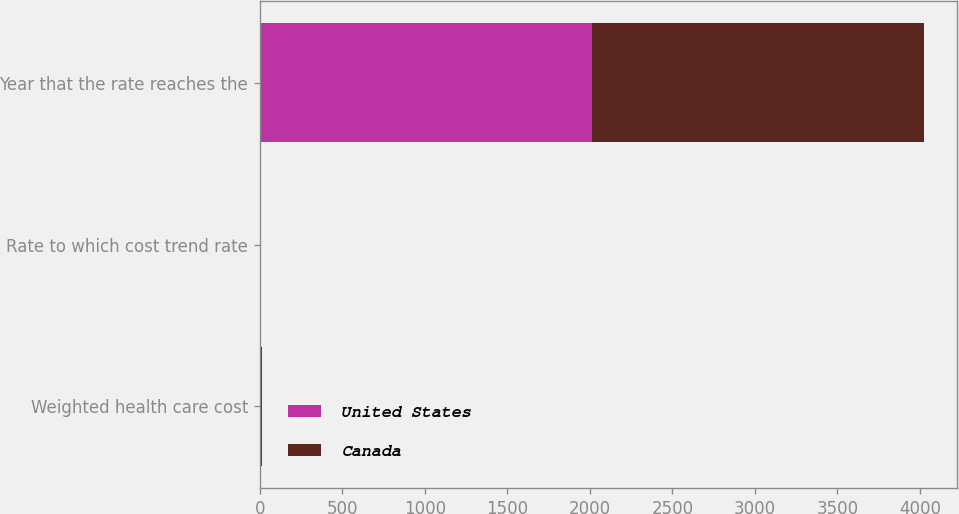<chart> <loc_0><loc_0><loc_500><loc_500><stacked_bar_chart><ecel><fcel>Weighted health care cost<fcel>Rate to which cost trend rate<fcel>Year that the rate reaches the<nl><fcel>United States<fcel>10<fcel>5<fcel>2013<nl><fcel>Canada<fcel>6.3<fcel>4.3<fcel>2011<nl></chart> 